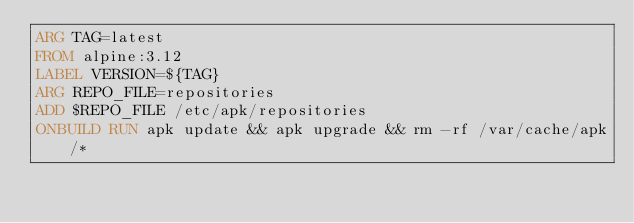<code> <loc_0><loc_0><loc_500><loc_500><_Dockerfile_>ARG TAG=latest
FROM alpine:3.12
LABEL VERSION=${TAG}
ARG REPO_FILE=repositories
ADD $REPO_FILE /etc/apk/repositories
ONBUILD RUN apk update && apk upgrade && rm -rf /var/cache/apk/*
</code> 